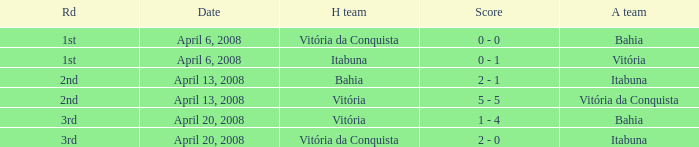On which date was the score 0 - 0? April 6, 2008. 